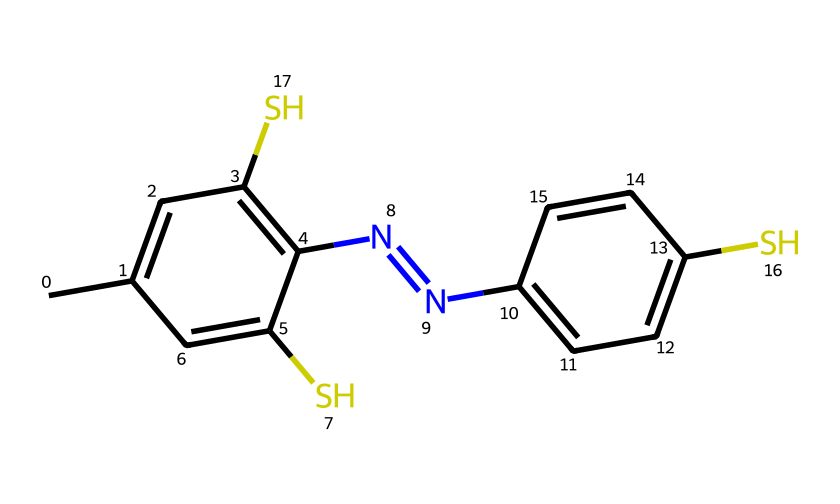What is the total number of sulfur atoms in this compound? The SMILES representation contains the letter 'S', which indicates sulfur atoms. By counting the occurrences of 'S', we find there are two sulfur atoms in the structure.
Answer: two How many nitrogen atoms are present in the molecule? The nitrogen atoms are represented by the letter 'N' in the SMILES string. There are two instances of 'N', indicating that there are two nitrogen atoms in total.
Answer: two What functional group is primarily responsible for the vibrant coloration in this compound? The presence of sulfur in the structure, particularly the thiol (–SH) groups, contributes to the vibrant coloration. The arrangement of the sulfur atoms and their connection to aromatic rings enhances the color properties.
Answer: thiol groups Which structural feature indicates that this compound can form strong intermolecular interactions, potentially affecting its dye properties? The presence of the nitrogen atoms within aromatic systems allows for hydrogen bonding and other interactions, which enhances solubility and dye affinity. This is crucial for the application of the dye in fabrics.
Answer: nitrogen atoms Is this compound likely to be soluble in water or organic solvents based on its structure? Given the presence of both sulfur and nitrogen atoms, along with the large aromatic portions, the molecule is more likely to be soluble in organic solvents than in water due to hydrophobic characteristics of aromatic rings.
Answer: organic solvents What type of chemical bonds connect the sulfur atoms in this compound? The sulfur atoms in this compound are connected by covalent bonds. This is determined from the structure as sulfur typically forms covalent bonds with other atoms in organosulfur compounds.
Answer: covalent bonds 